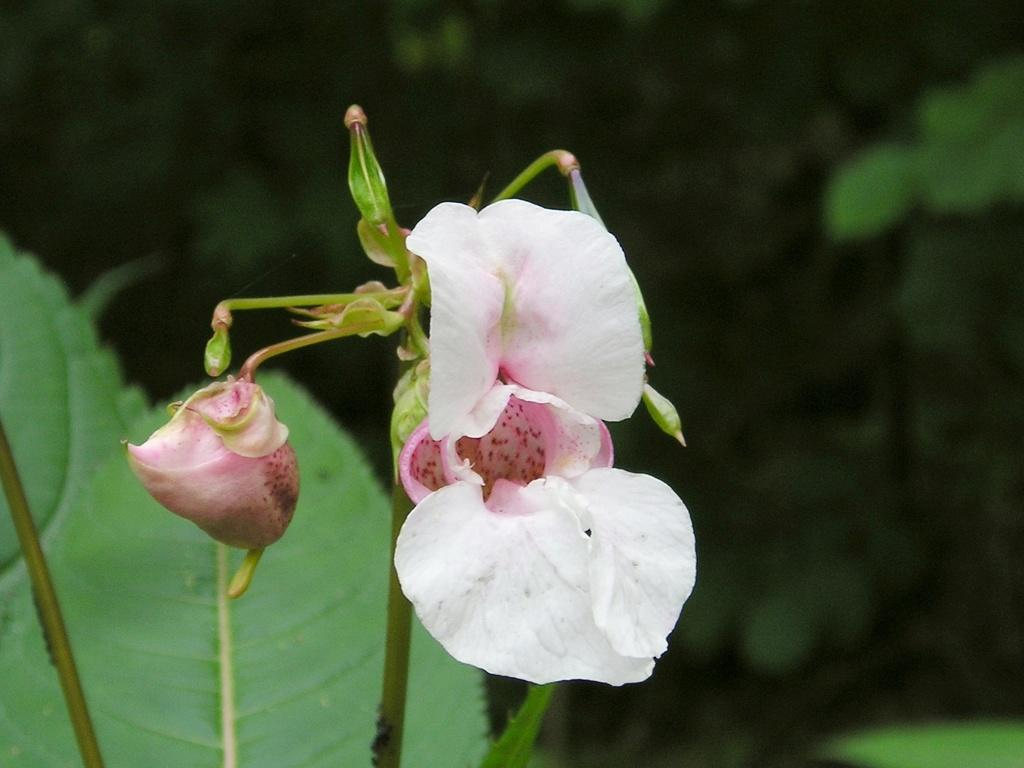What type of plant is the main subject of the image? There is a plant with flowers and buds in the image. How is the background of the image depicted? In the background, the image is blurred. What can be seen in the background besides the blurred area? Leaves and other plants are visible in the background of the image. How many ladybugs can be seen on the plant in the image? There are no ladybugs present in the image; it only features a plant with flowers and buds. What channel is the image from? The image is not from a channel, as it is a still photograph and not a video or broadcast. 